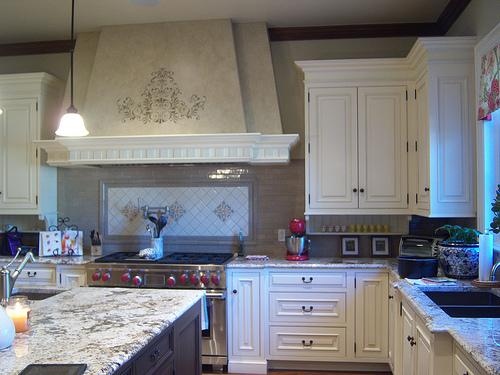Question: what are the cabinets made of?
Choices:
A. Plastic.
B. Granite.
C. Marble.
D. Wood.
Answer with the letter. Answer: D Question: how many people are in this picture?
Choices:
A. Two.
B. Five.
C. Six.
D. None.
Answer with the letter. Answer: D Question: where is this room?
Choices:
A. The living room.
B. The bedroom.
C. The kitchen.
D. The bathroom.
Answer with the letter. Answer: C 